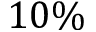<formula> <loc_0><loc_0><loc_500><loc_500>1 0 \%</formula> 